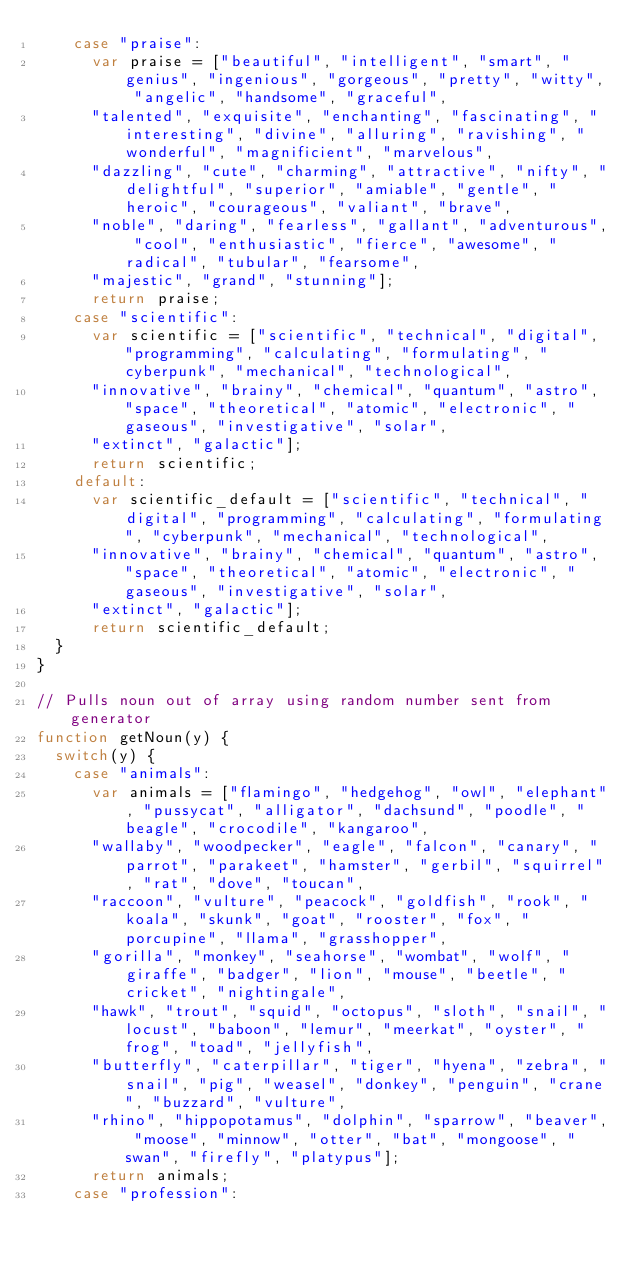<code> <loc_0><loc_0><loc_500><loc_500><_JavaScript_>    case "praise":
      var praise = ["beautiful", "intelligent", "smart", "genius", "ingenious", "gorgeous", "pretty", "witty", "angelic", "handsome", "graceful",
      "talented", "exquisite", "enchanting", "fascinating", "interesting", "divine", "alluring", "ravishing", "wonderful", "magnificient", "marvelous",
      "dazzling", "cute", "charming", "attractive", "nifty", "delightful", "superior", "amiable", "gentle", "heroic", "courageous", "valiant", "brave",
      "noble", "daring", "fearless", "gallant", "adventurous", "cool", "enthusiastic", "fierce", "awesome", "radical", "tubular", "fearsome",
      "majestic", "grand", "stunning"];
      return praise;
    case "scientific":
      var scientific = ["scientific", "technical", "digital", "programming", "calculating", "formulating", "cyberpunk", "mechanical", "technological",
      "innovative", "brainy", "chemical", "quantum", "astro", "space", "theoretical", "atomic", "electronic", "gaseous", "investigative", "solar",
      "extinct", "galactic"];
      return scientific;
    default:
      var scientific_default = ["scientific", "technical", "digital", "programming", "calculating", "formulating", "cyberpunk", "mechanical", "technological",
      "innovative", "brainy", "chemical", "quantum", "astro", "space", "theoretical", "atomic", "electronic", "gaseous", "investigative", "solar",
      "extinct", "galactic"];
      return scientific_default;
  }
}

// Pulls noun out of array using random number sent from generator
function getNoun(y) {
  switch(y) {
    case "animals":
      var animals = ["flamingo", "hedgehog", "owl", "elephant", "pussycat", "alligator", "dachsund", "poodle", "beagle", "crocodile", "kangaroo",
      "wallaby", "woodpecker", "eagle", "falcon", "canary", "parrot", "parakeet", "hamster", "gerbil", "squirrel", "rat", "dove", "toucan",
      "raccoon", "vulture", "peacock", "goldfish", "rook", "koala", "skunk", "goat", "rooster", "fox", "porcupine", "llama", "grasshopper",
      "gorilla", "monkey", "seahorse", "wombat", "wolf", "giraffe", "badger", "lion", "mouse", "beetle", "cricket", "nightingale",
      "hawk", "trout", "squid", "octopus", "sloth", "snail", "locust", "baboon", "lemur", "meerkat", "oyster", "frog", "toad", "jellyfish",
      "butterfly", "caterpillar", "tiger", "hyena", "zebra", "snail", "pig", "weasel", "donkey", "penguin", "crane", "buzzard", "vulture",
      "rhino", "hippopotamus", "dolphin", "sparrow", "beaver", "moose", "minnow", "otter", "bat", "mongoose", "swan", "firefly", "platypus"];
      return animals;
    case "profession":</code> 